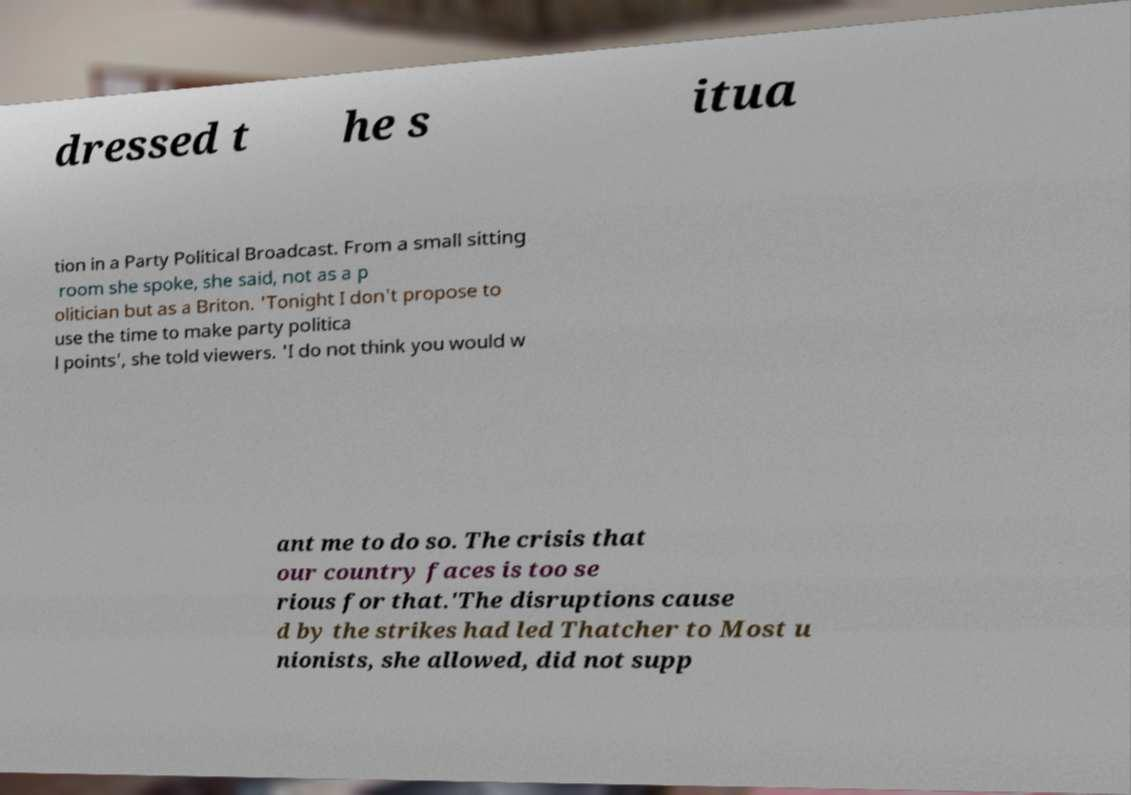Can you read and provide the text displayed in the image?This photo seems to have some interesting text. Can you extract and type it out for me? dressed t he s itua tion in a Party Political Broadcast. From a small sitting room she spoke, she said, not as a p olitician but as a Briton. 'Tonight I don't propose to use the time to make party politica l points', she told viewers. 'I do not think you would w ant me to do so. The crisis that our country faces is too se rious for that.'The disruptions cause d by the strikes had led Thatcher to Most u nionists, she allowed, did not supp 